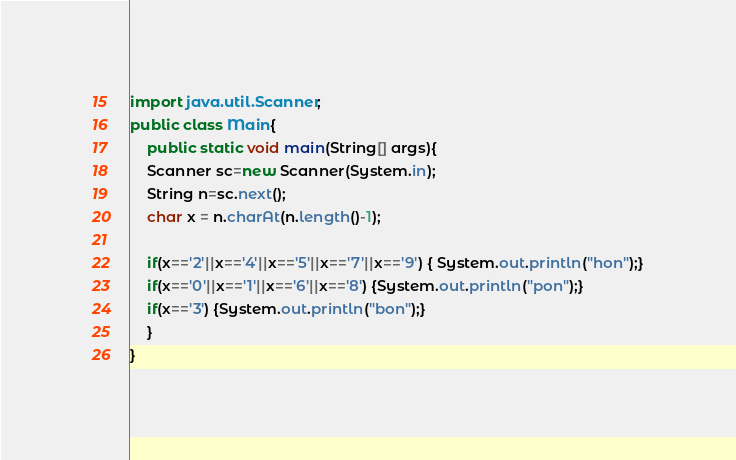Convert code to text. <code><loc_0><loc_0><loc_500><loc_500><_Java_>import java.util.Scanner;
public class Main{
	public static void main(String[] args){
	Scanner sc=new Scanner(System.in);
	String n=sc.next();
	char x = n.charAt(n.length()-1);

	if(x=='2'||x=='4'||x=='5'||x=='7'||x=='9') { System.out.println("hon");}
	if(x=='0'||x=='1'||x=='6'||x=='8') {System.out.println("pon");}
	if(x=='3') {System.out.println("bon");}
	}
}</code> 